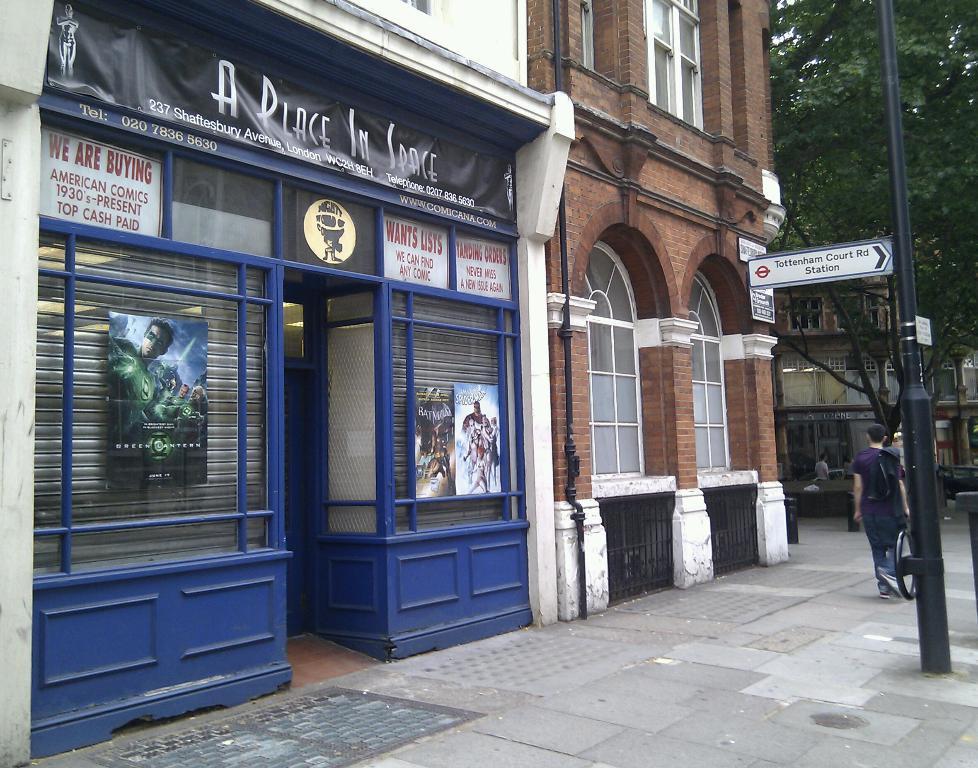How would you summarize this image in a sentence or two? In this image I can see the ground, few persons standing on the ground, a black colored pole, few boards attached to the pole, few buildings which are brown, white and blue in color , few windows of the buildings and few banners to the buildings. I can see few posts to the building and in the background I can see another building and a tree which is green in color. 